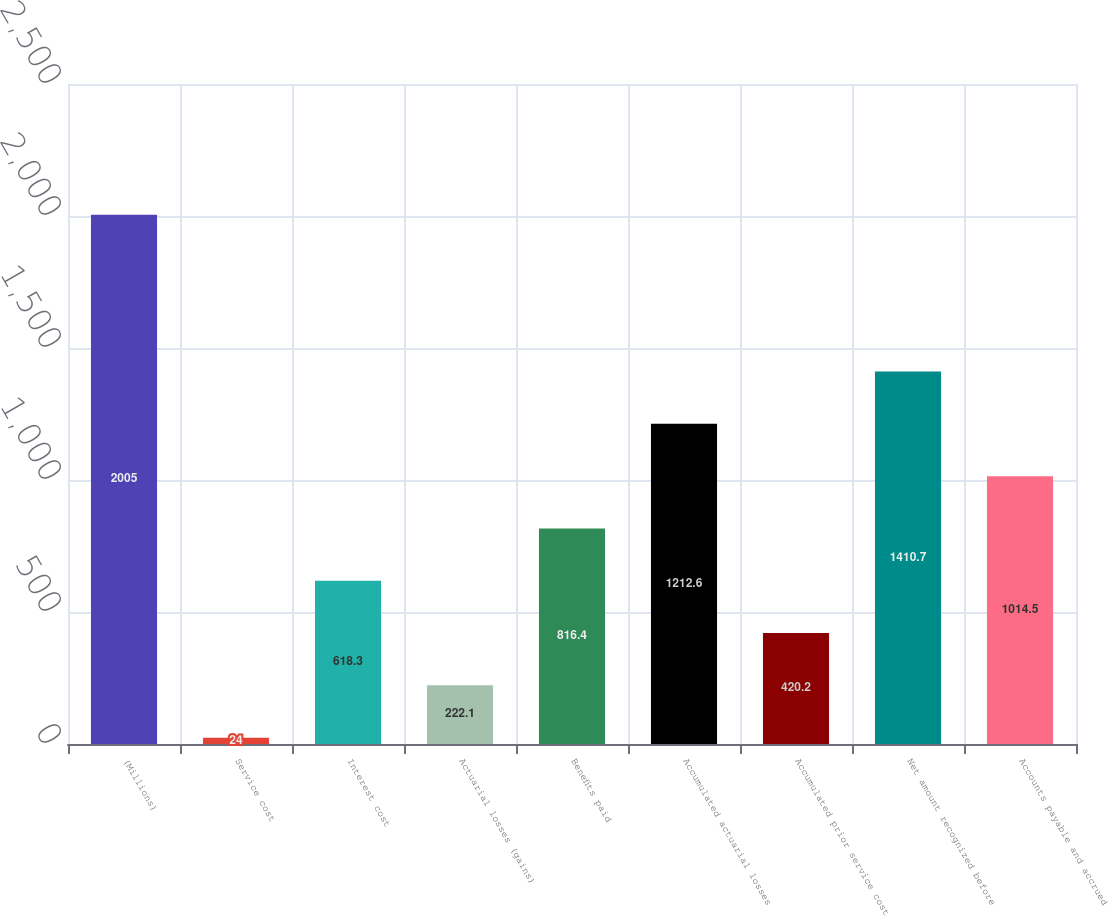<chart> <loc_0><loc_0><loc_500><loc_500><bar_chart><fcel>(Millions)<fcel>Service cost<fcel>Interest cost<fcel>Actuarial losses (gains)<fcel>Benefits paid<fcel>Accumulated actuarial losses<fcel>Accumulated prior service cost<fcel>Net amount recognized before<fcel>Accounts payable and accrued<nl><fcel>2005<fcel>24<fcel>618.3<fcel>222.1<fcel>816.4<fcel>1212.6<fcel>420.2<fcel>1410.7<fcel>1014.5<nl></chart> 